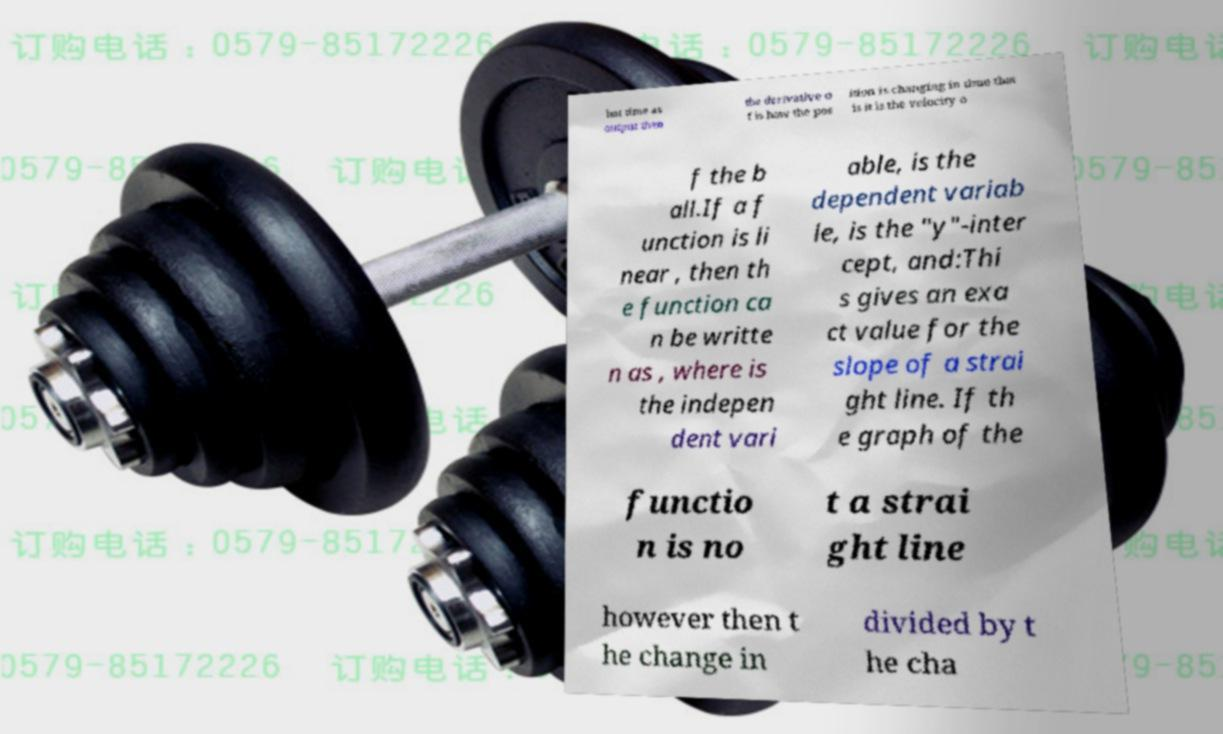Could you extract and type out the text from this image? hat time as output then the derivative o f is how the pos ition is changing in time that is it is the velocity o f the b all.If a f unction is li near , then th e function ca n be writte n as , where is the indepen dent vari able, is the dependent variab le, is the "y"-inter cept, and:Thi s gives an exa ct value for the slope of a strai ght line. If th e graph of the functio n is no t a strai ght line however then t he change in divided by t he cha 